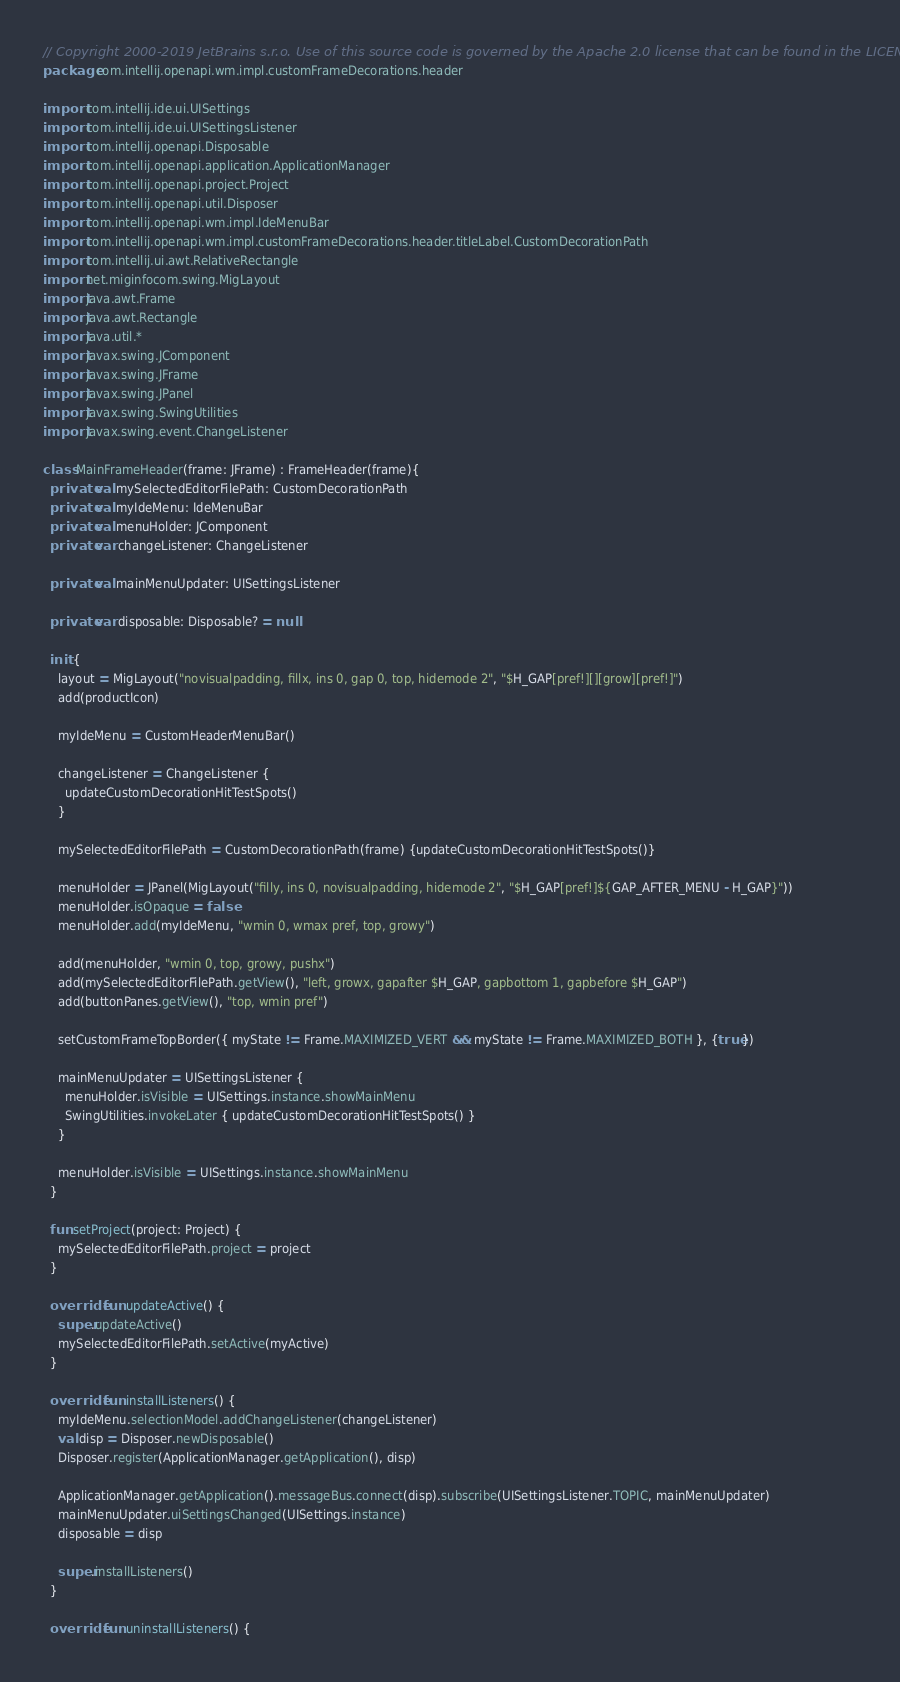<code> <loc_0><loc_0><loc_500><loc_500><_Kotlin_>// Copyright 2000-2019 JetBrains s.r.o. Use of this source code is governed by the Apache 2.0 license that can be found in the LICENSE file.
package com.intellij.openapi.wm.impl.customFrameDecorations.header

import com.intellij.ide.ui.UISettings
import com.intellij.ide.ui.UISettingsListener
import com.intellij.openapi.Disposable
import com.intellij.openapi.application.ApplicationManager
import com.intellij.openapi.project.Project
import com.intellij.openapi.util.Disposer
import com.intellij.openapi.wm.impl.IdeMenuBar
import com.intellij.openapi.wm.impl.customFrameDecorations.header.titleLabel.CustomDecorationPath
import com.intellij.ui.awt.RelativeRectangle
import net.miginfocom.swing.MigLayout
import java.awt.Frame
import java.awt.Rectangle
import java.util.*
import javax.swing.JComponent
import javax.swing.JFrame
import javax.swing.JPanel
import javax.swing.SwingUtilities
import javax.swing.event.ChangeListener

class MainFrameHeader(frame: JFrame) : FrameHeader(frame){
  private val mySelectedEditorFilePath: CustomDecorationPath
  private val myIdeMenu: IdeMenuBar
  private val menuHolder: JComponent
  private var changeListener: ChangeListener

  private val mainMenuUpdater: UISettingsListener

  private var disposable: Disposable? = null

  init {
    layout = MigLayout("novisualpadding, fillx, ins 0, gap 0, top, hidemode 2", "$H_GAP[pref!][][grow][pref!]")
    add(productIcon)

    myIdeMenu = CustomHeaderMenuBar()

    changeListener = ChangeListener {
      updateCustomDecorationHitTestSpots()
    }

    mySelectedEditorFilePath = CustomDecorationPath(frame) {updateCustomDecorationHitTestSpots()}

    menuHolder = JPanel(MigLayout("filly, ins 0, novisualpadding, hidemode 2", "$H_GAP[pref!]${GAP_AFTER_MENU - H_GAP}"))
    menuHolder.isOpaque = false
    menuHolder.add(myIdeMenu, "wmin 0, wmax pref, top, growy")

    add(menuHolder, "wmin 0, top, growy, pushx")
    add(mySelectedEditorFilePath.getView(), "left, growx, gapafter $H_GAP, gapbottom 1, gapbefore $H_GAP")
    add(buttonPanes.getView(), "top, wmin pref")

    setCustomFrameTopBorder({ myState != Frame.MAXIMIZED_VERT && myState != Frame.MAXIMIZED_BOTH }, {true})

    mainMenuUpdater = UISettingsListener {
      menuHolder.isVisible = UISettings.instance.showMainMenu
      SwingUtilities.invokeLater { updateCustomDecorationHitTestSpots() }
    }

    menuHolder.isVisible = UISettings.instance.showMainMenu
  }

  fun setProject(project: Project) {
    mySelectedEditorFilePath.project = project
  }

  override fun updateActive() {
    super.updateActive()
    mySelectedEditorFilePath.setActive(myActive)
  }

  override fun installListeners() {
    myIdeMenu.selectionModel.addChangeListener(changeListener)
    val disp = Disposer.newDisposable()
    Disposer.register(ApplicationManager.getApplication(), disp)

    ApplicationManager.getApplication().messageBus.connect(disp).subscribe(UISettingsListener.TOPIC, mainMenuUpdater)
    mainMenuUpdater.uiSettingsChanged(UISettings.instance)
    disposable = disp

    super.installListeners()
  }

  override fun uninstallListeners() {</code> 